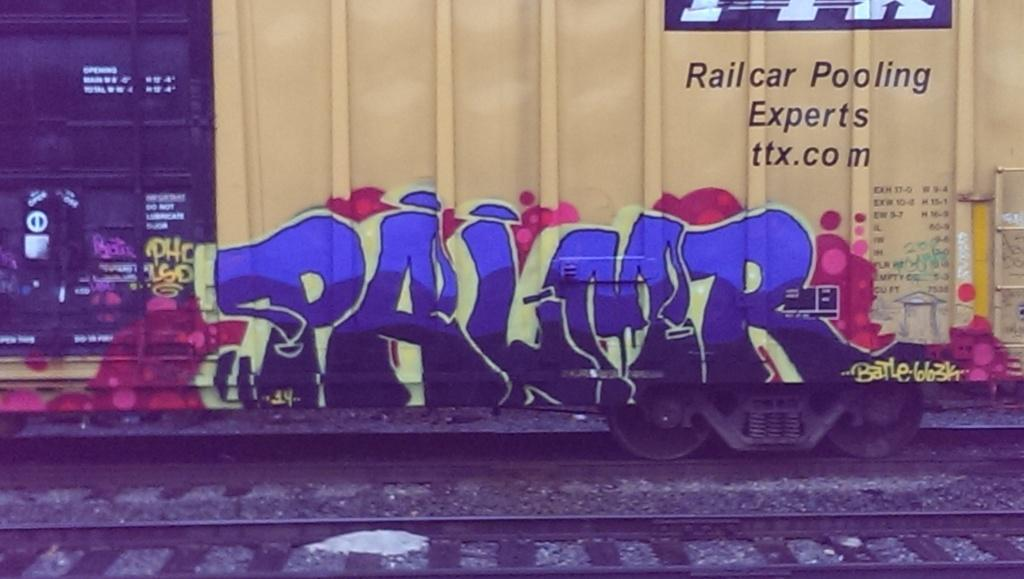<image>
Describe the image concisely. A train car with grafiti on it that says PALMR. 